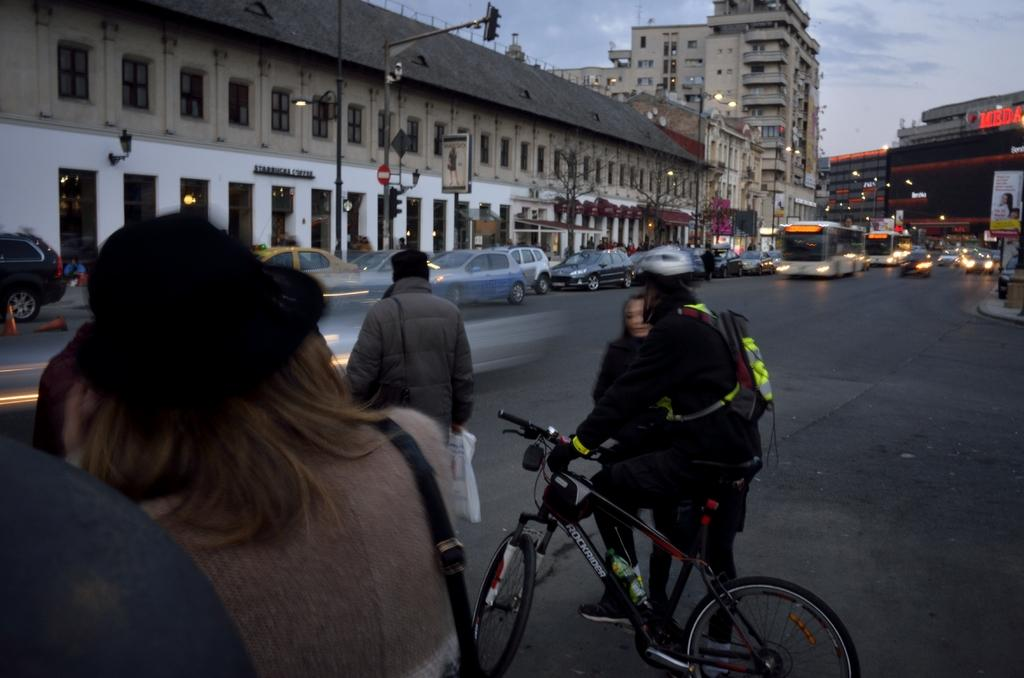What is the main subject of the image? There is a person riding a bicycle in the image. What else can be seen on the road in the image? There are vehicles on the road in the image. Are there any other people visible in the image? Yes, there are people standing on the road in the image. What can be seen in the background of the image? There is a building visible in the background of the image. What type of food is the person riding the bicycle desiring in the image? There is no indication of food or desire in the image; it simply shows a person riding a bicycle and other elements on the road and in the background. 